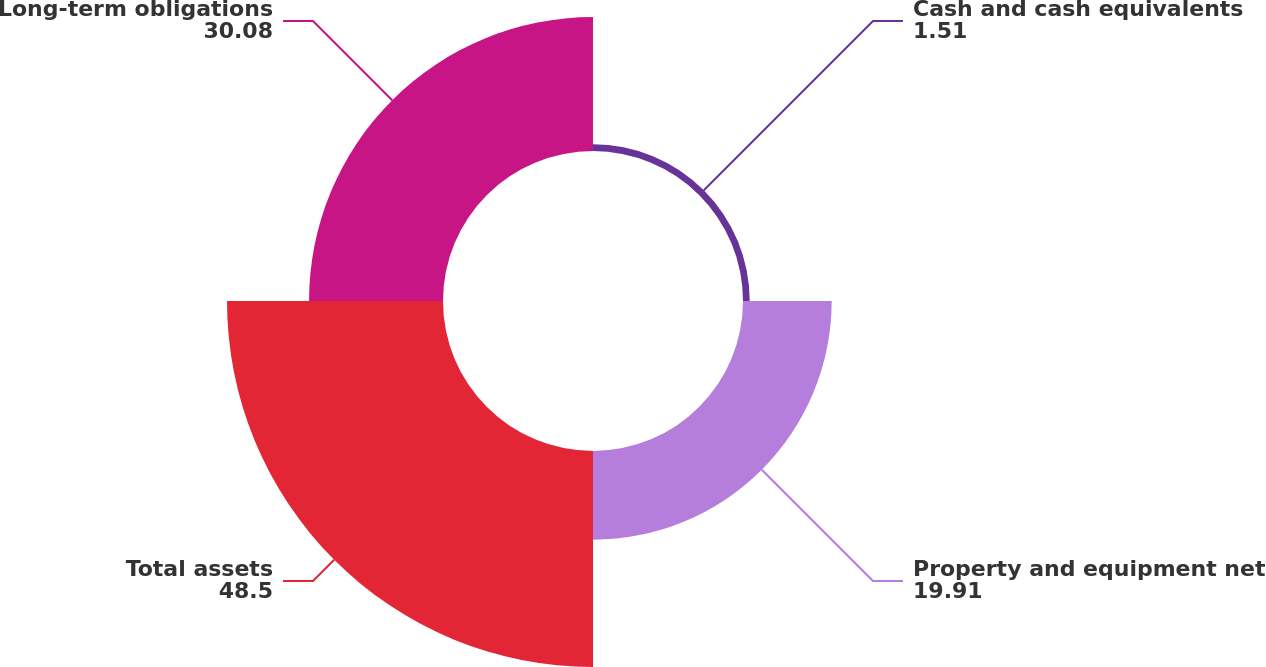Convert chart to OTSL. <chart><loc_0><loc_0><loc_500><loc_500><pie_chart><fcel>Cash and cash equivalents<fcel>Property and equipment net<fcel>Total assets<fcel>Long-term obligations<nl><fcel>1.51%<fcel>19.91%<fcel>48.5%<fcel>30.08%<nl></chart> 